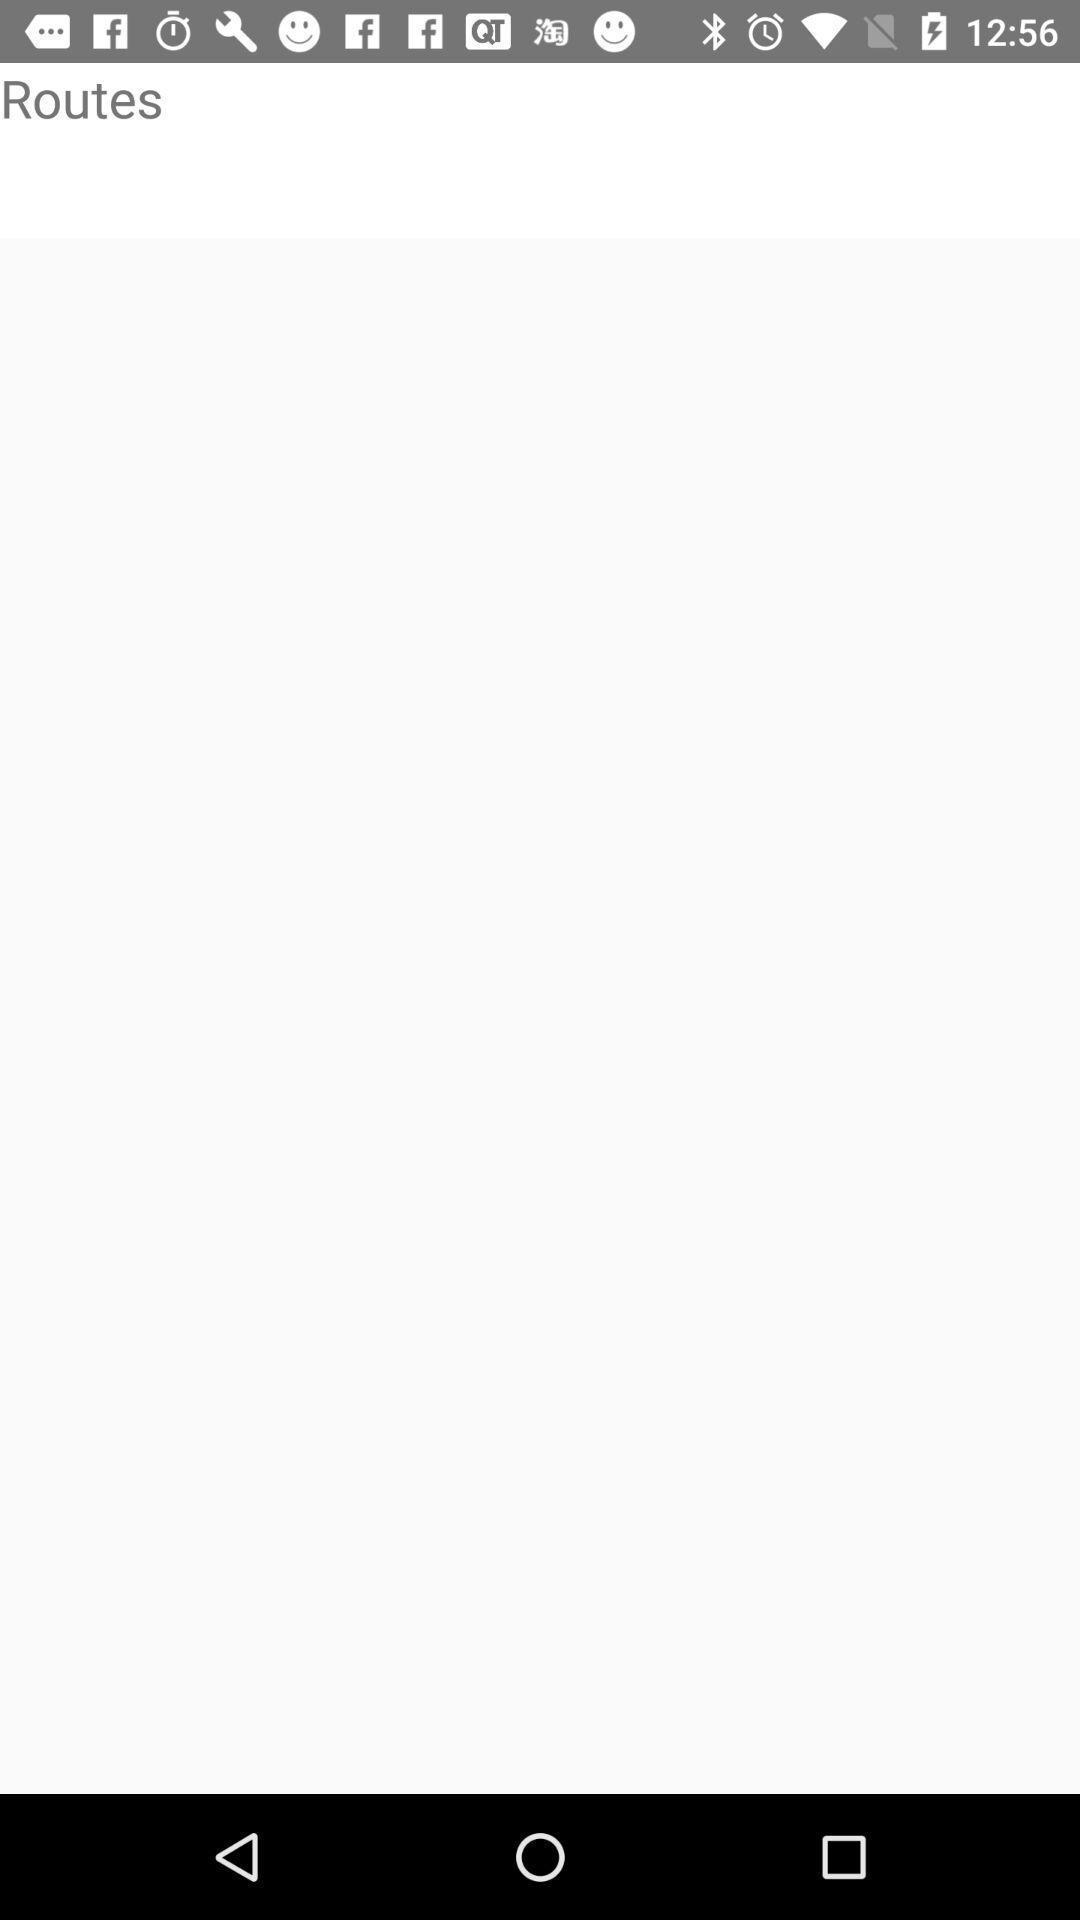Tell me what you see in this picture. Routes page. 